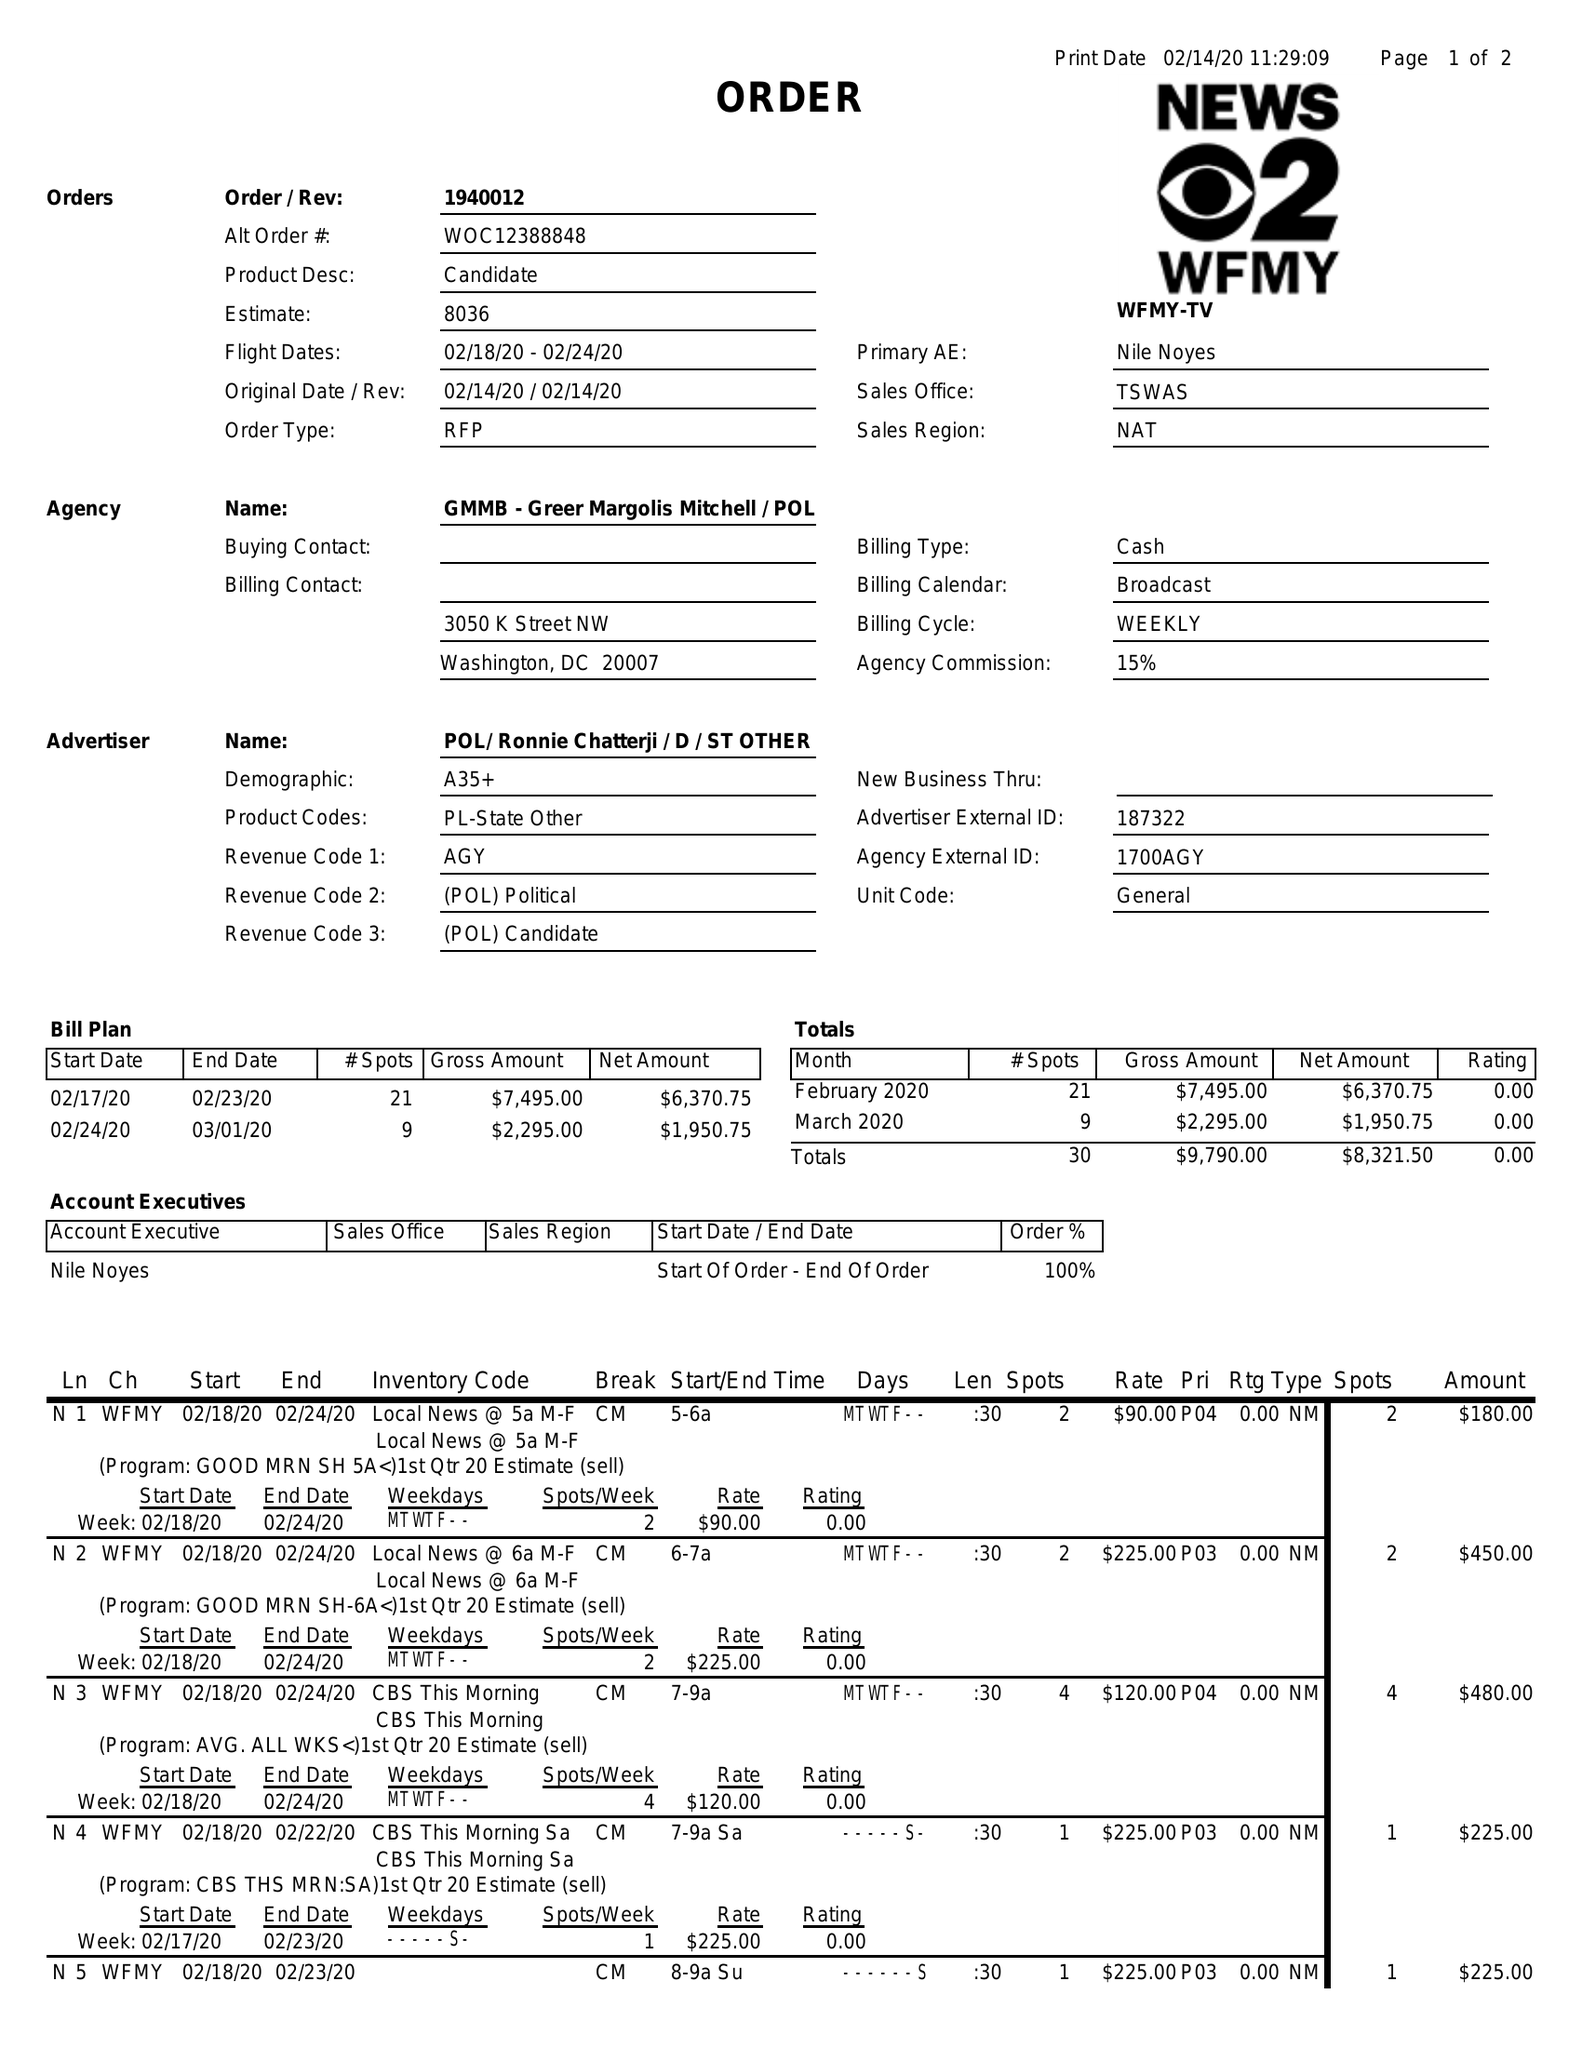What is the value for the advertiser?
Answer the question using a single word or phrase. POL/RONNIECHATTERJI/D/STOTHER 